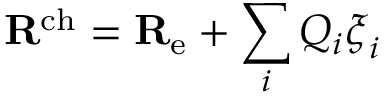<formula> <loc_0><loc_0><loc_500><loc_500>R ^ { c h } = R _ { e } + \sum _ { i } Q _ { i } \xi _ { i }</formula> 